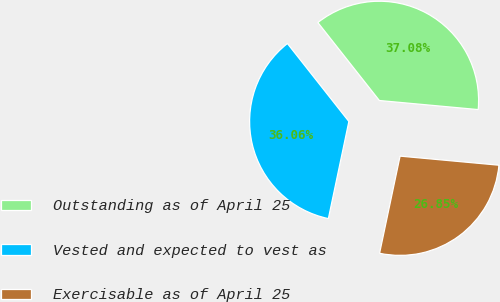Convert chart. <chart><loc_0><loc_0><loc_500><loc_500><pie_chart><fcel>Outstanding as of April 25<fcel>Vested and expected to vest as<fcel>Exercisable as of April 25<nl><fcel>37.08%<fcel>36.06%<fcel>26.85%<nl></chart> 